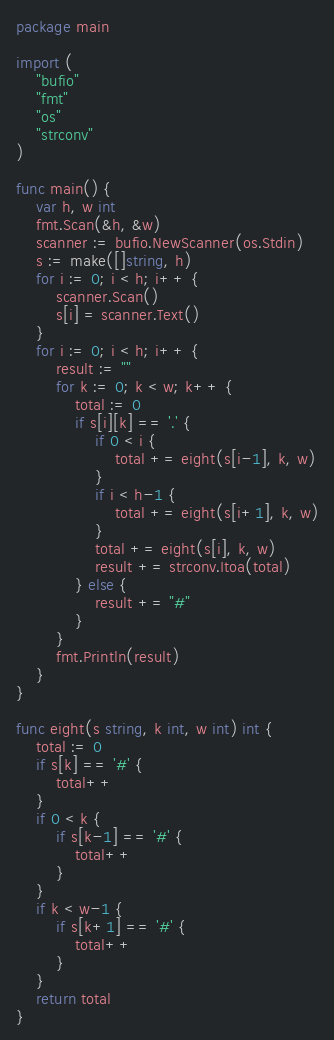Convert code to text. <code><loc_0><loc_0><loc_500><loc_500><_Go_>package main

import (
	"bufio"
	"fmt"
	"os"
	"strconv"
)

func main() {
	var h, w int
	fmt.Scan(&h, &w)
	scanner := bufio.NewScanner(os.Stdin)
	s := make([]string, h)
	for i := 0; i < h; i++ {
		scanner.Scan()
		s[i] = scanner.Text()
	}
	for i := 0; i < h; i++ {
		result := ""
		for k := 0; k < w; k++ {
			total := 0
			if s[i][k] == '.' {
				if 0 < i {
					total += eight(s[i-1], k, w)
				}
				if i < h-1 {
					total += eight(s[i+1], k, w)
				}
				total += eight(s[i], k, w)
				result += strconv.Itoa(total)
			} else {
				result += "#"
			}
		}
		fmt.Println(result)
	}
}

func eight(s string, k int, w int) int {
	total := 0
	if s[k] == '#' {
		total++
	}
	if 0 < k {
		if s[k-1] == '#' {
			total++
		}
	}
	if k < w-1 {
		if s[k+1] == '#' {
			total++
		}
	}
	return total
}</code> 